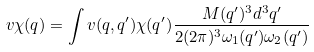Convert formula to latex. <formula><loc_0><loc_0><loc_500><loc_500>v \chi ( { q } ) = \int \nolimits v ( { q } , { q } ^ { \prime } ) \chi ( { q } ^ { \prime } ) \frac { M ( { q } ^ { \prime } ) ^ { 3 } d ^ { 3 } { q } ^ { \prime } } { 2 ( 2 \pi ) ^ { 3 } \omega _ { 1 } ( { q } ^ { \prime } ) \omega _ { 2 } ( { q } ^ { \prime } ) }</formula> 